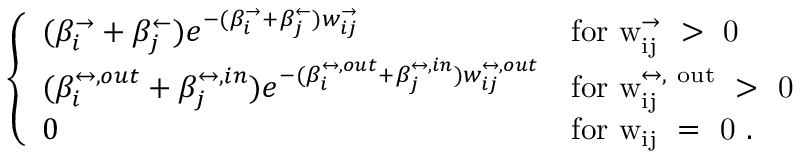Convert formula to latex. <formula><loc_0><loc_0><loc_500><loc_500>\left \{ \begin{array} { l l } { ( \beta _ { i } ^ { \rightarrow } + \beta _ { j } ^ { \leftarrow } ) e ^ { - ( \beta _ { i } ^ { \rightarrow } + \beta _ { j } ^ { \leftarrow } ) w _ { i j } ^ { \rightarrow } } } & { f o r w _ { i j } ^ { \rightarrow } > 0 } \\ { ( \beta _ { i } ^ { \leftrightarrow , o u t } + \beta _ { j } ^ { \leftrightarrow , i n } ) e ^ { - ( \beta _ { i } ^ { \leftrightarrow , o u t } + \beta _ { j } ^ { \leftrightarrow , i n } ) w _ { i j } ^ { \leftrightarrow , o u t } } } & { f o r w _ { i j } ^ { \leftrightarrow , o u t } > 0 } \\ { 0 } & { f o r w _ { i j } = 0 . } \end{array}</formula> 